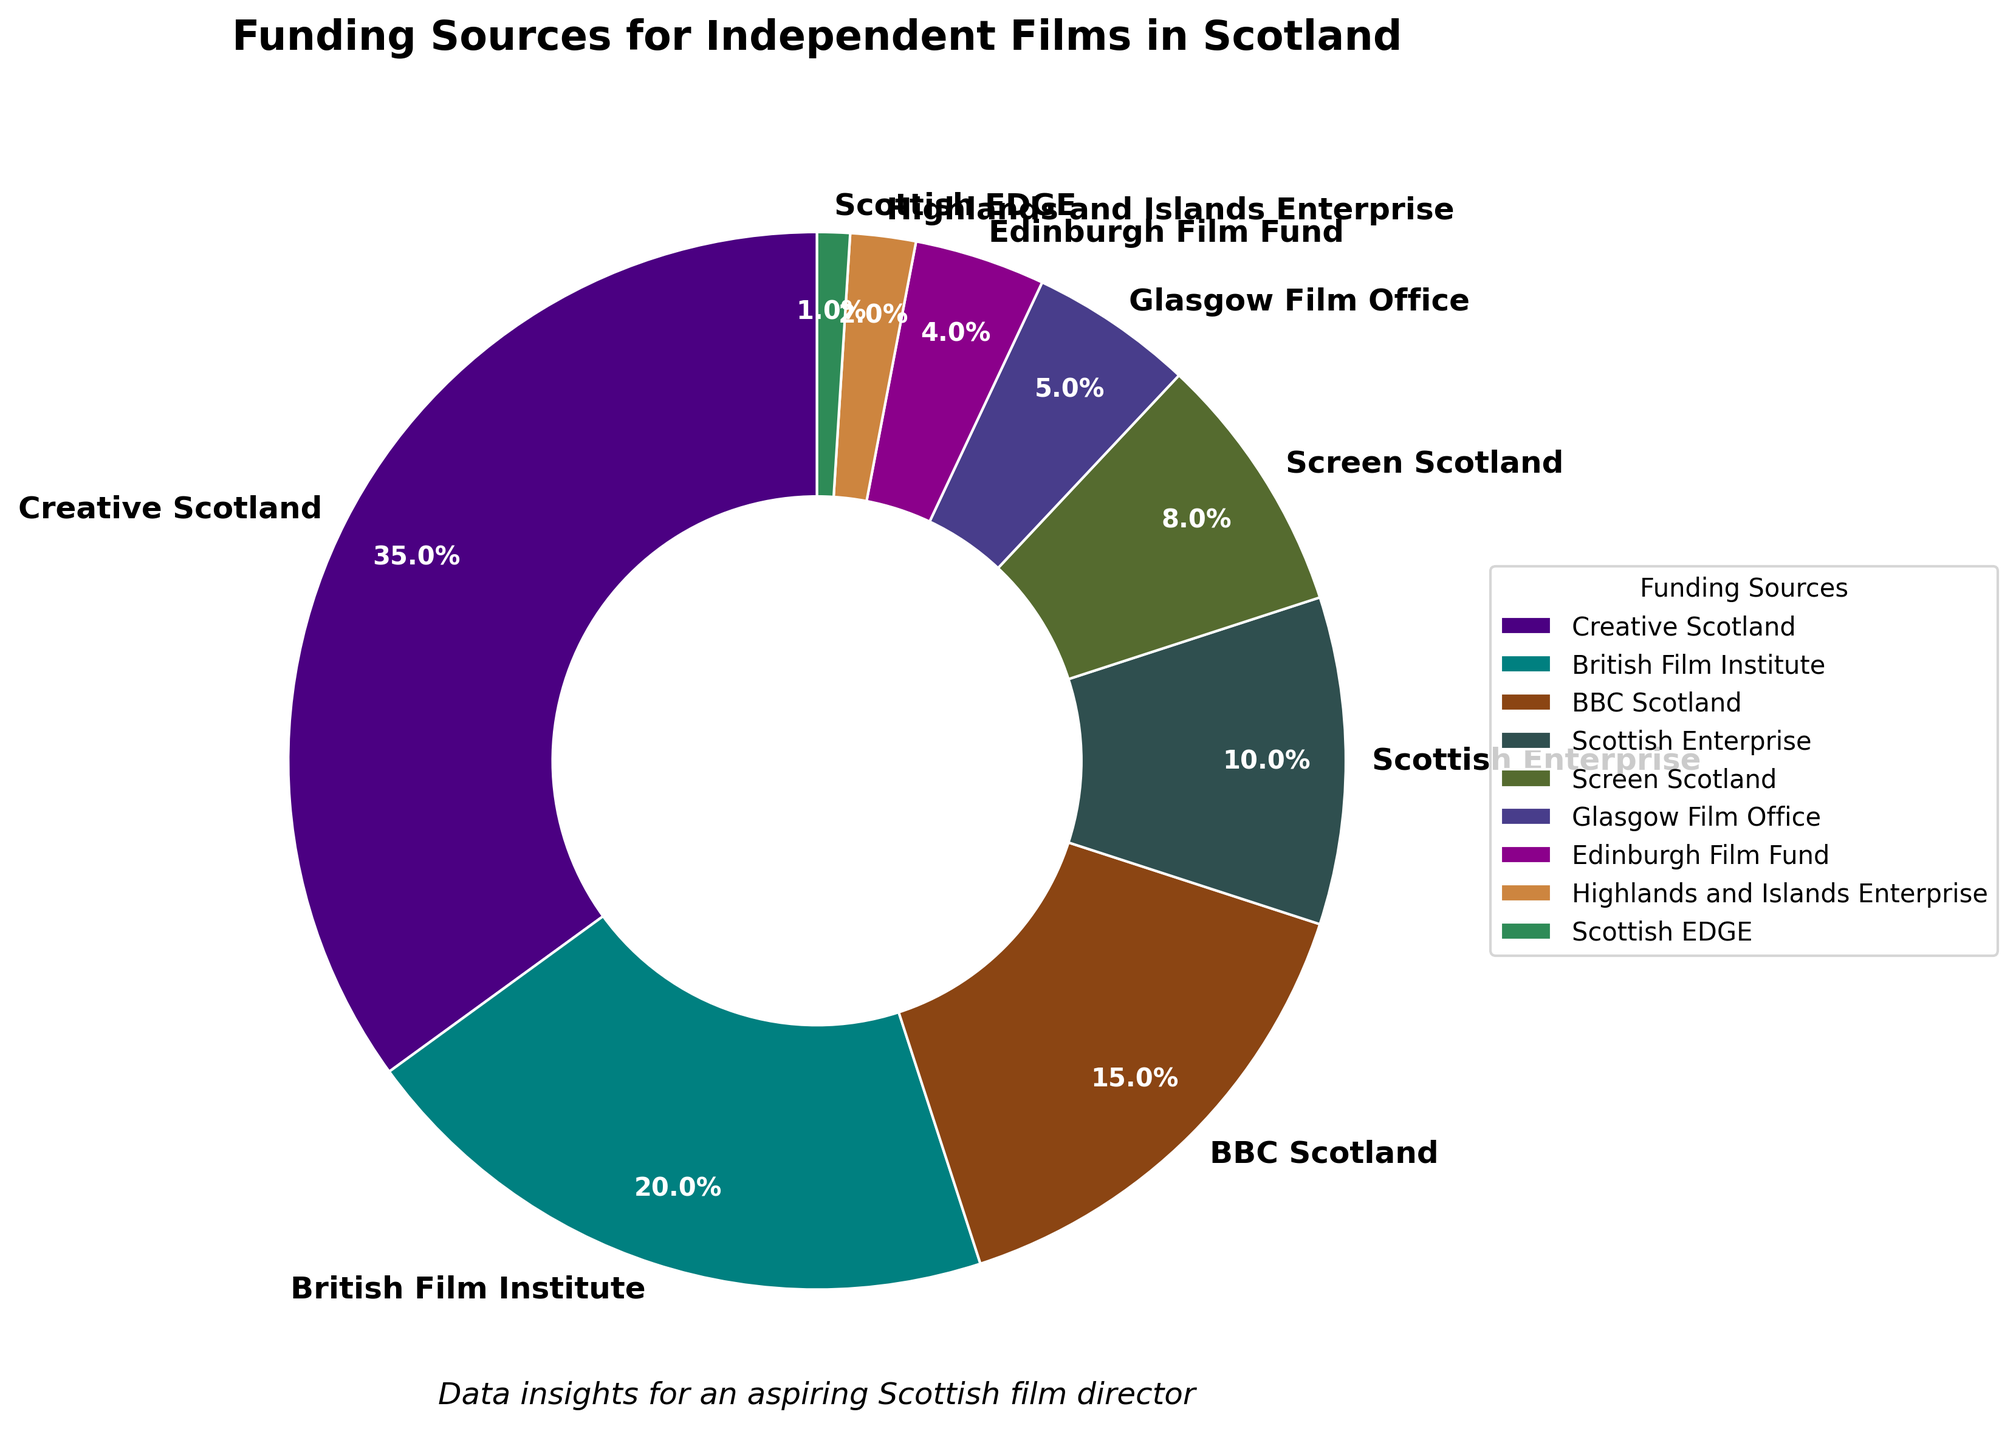Which funding source contributes the highest percentage to independent films in Scotland? The funding source with the highest percentage in the pie chart is Creative Scotland.
Answer: Creative Scotland What is the combined percentage of BBC Scotland and the British Film Institute? Add the percentage of BBC Scotland (15%) and the British Film Institute (20%). 15 + 20 = 35
Answer: 35 How much more funding does Creative Scotland provide compared to Screen Scotland? Subtract the percentage of Screen Scotland (8%) from the percentage of Creative Scotland (35%). 35 - 8 = 27
Answer: 27 Which funding source contributes the least to independent films in Scotland? The funding source with the smallest percentage in the pie chart is Scottish EDGE.
Answer: Scottish EDGE Is the combined percentage of Glasgow Film Office and Edinburgh Film Fund greater than that of Scottish Enterprise? Add the percentage of Glasgow Film Office (5%) and Edinburgh Film Fund (4%) and compare it to Scottish Enterprise's percentage (10%). 5 + 4 = 9, which is less than 10.
Answer: No What is the percentage difference between BBC Scotland and Scottish Enterprise? Subtract the percentage of Scottish Enterprise (10%) from BBC Scotland (15%). 15 - 10 = 5
Answer: 5 Which funding sources contribute a total of 50% when combined? Add the percentages and find combinations that sum up to 50%. One such combination is Creative Scotland (35%) and British Film Institute (15%).
Answer: Creative Scotland and British Film Institute Rank the top three funding sources in terms of their contributions. Order the funding sources by their percentages: 1) Creative Scotland (35%), 2) British Film Institute (20%), 3) BBC Scotland (15%).
Answer: Creative Scotland, British Film Institute, BBC Scotland Which sources have funding percentages less than 10%? Identify the funding sources with percentages less than 10%, which are: Screen Scotland (8%), Glasgow Film Office (5%), Edinburgh Film Fund (4%), Highlands and Islands Enterprise (2%), and Scottish EDGE (1%).
Answer: Screen Scotland, Glasgow Film Office, Edinburgh Film Fund, Highlands and Islands Enterprise, Scottish EDGE How does the funding percentage from Highlands and Islands Enterprise compare to Screen Scotland? Compare the percentages of Highlands and Islands Enterprise (2%) and Screen Scotland (8%). 2 is less than 8.
Answer: Highlands and Islands Enterprise contributes less 